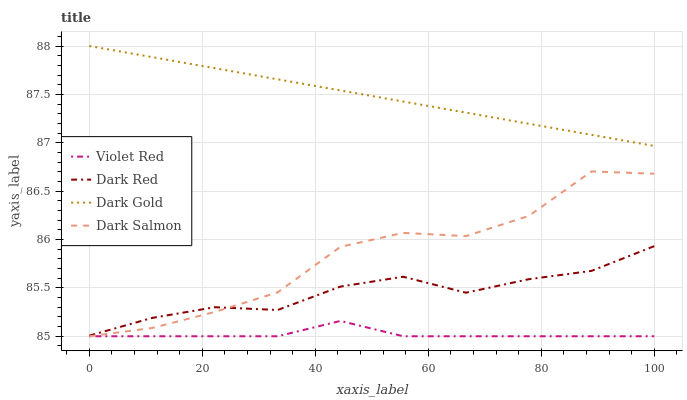Does Dark Salmon have the minimum area under the curve?
Answer yes or no. No. Does Dark Salmon have the maximum area under the curve?
Answer yes or no. No. Is Violet Red the smoothest?
Answer yes or no. No. Is Violet Red the roughest?
Answer yes or no. No. Does Dark Gold have the lowest value?
Answer yes or no. No. Does Dark Salmon have the highest value?
Answer yes or no. No. Is Dark Red less than Dark Gold?
Answer yes or no. Yes. Is Dark Gold greater than Dark Red?
Answer yes or no. Yes. Does Dark Red intersect Dark Gold?
Answer yes or no. No. 